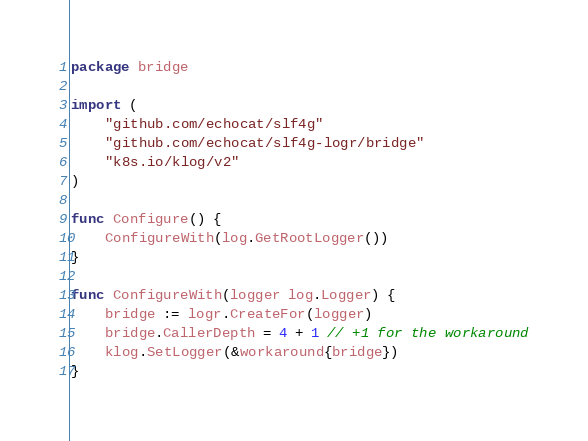<code> <loc_0><loc_0><loc_500><loc_500><_Go_>package bridge

import (
	"github.com/echocat/slf4g"
	"github.com/echocat/slf4g-logr/bridge"
	"k8s.io/klog/v2"
)

func Configure() {
	ConfigureWith(log.GetRootLogger())
}

func ConfigureWith(logger log.Logger) {
	bridge := logr.CreateFor(logger)
	bridge.CallerDepth = 4 + 1 // +1 for the workaround
	klog.SetLogger(&workaround{bridge})
}
</code> 